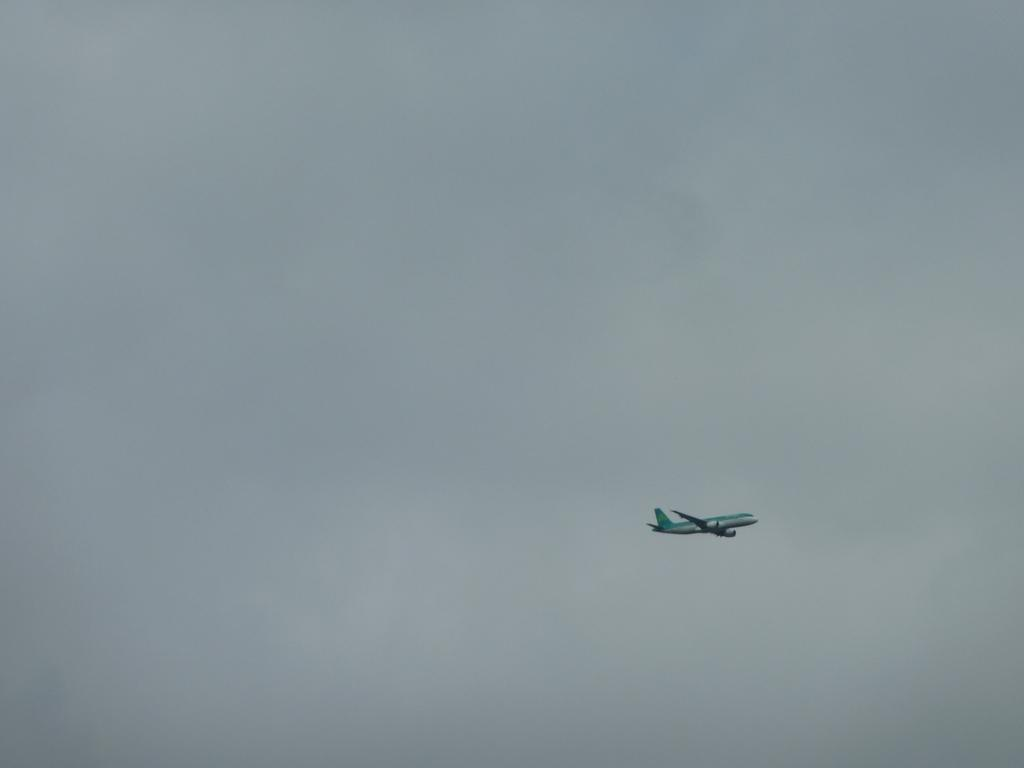What is the main subject of the image? There is a plane in the middle of the image. What can be seen in the sky in the image? There are clouds in the sky. What is visible in the background of the image? The sky is visible in the image. What type of curtain can be seen hanging from the plane in the image? There is no curtain present on the plane in the image. 